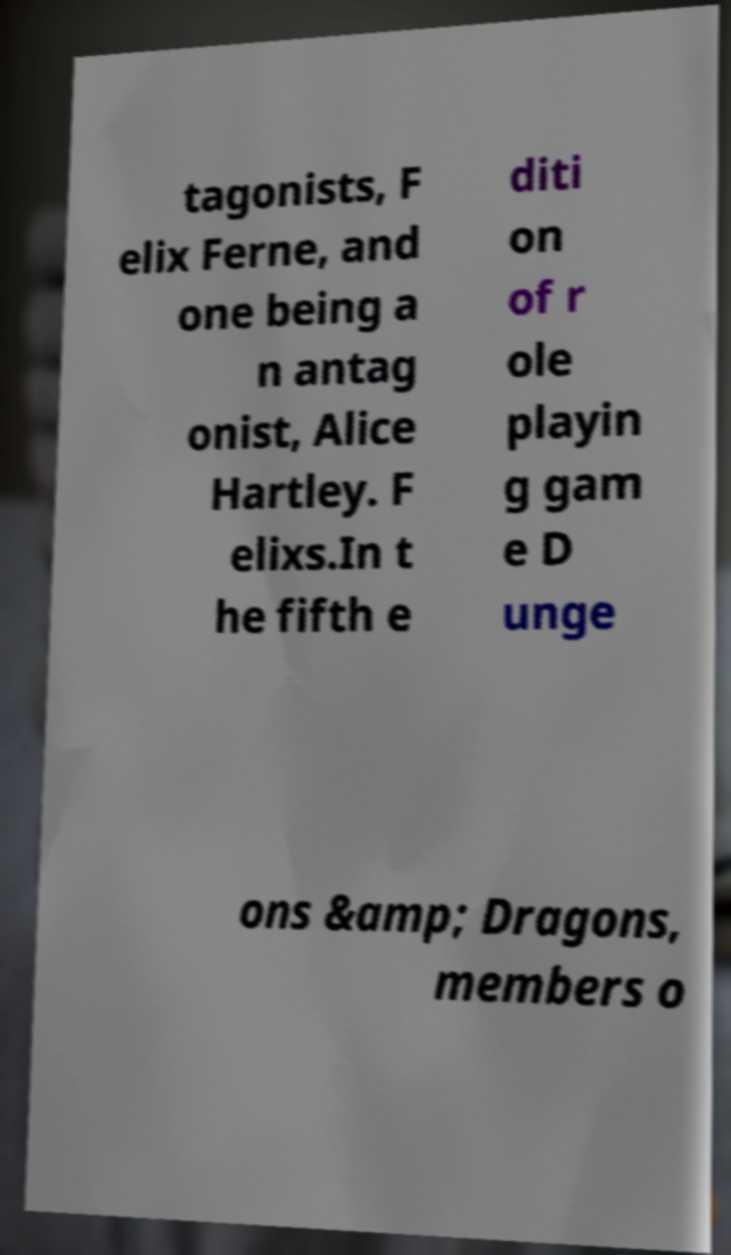Can you read and provide the text displayed in the image?This photo seems to have some interesting text. Can you extract and type it out for me? tagonists, F elix Ferne, and one being a n antag onist, Alice Hartley. F elixs.In t he fifth e diti on of r ole playin g gam e D unge ons &amp; Dragons, members o 